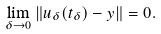Convert formula to latex. <formula><loc_0><loc_0><loc_500><loc_500>\ \lim _ { \delta \to 0 } \| u _ { \delta } ( t _ { \delta } ) - y \| = 0 .</formula> 